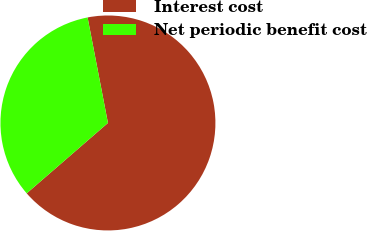Convert chart to OTSL. <chart><loc_0><loc_0><loc_500><loc_500><pie_chart><fcel>Interest cost<fcel>Net periodic benefit cost<nl><fcel>66.67%<fcel>33.33%<nl></chart> 